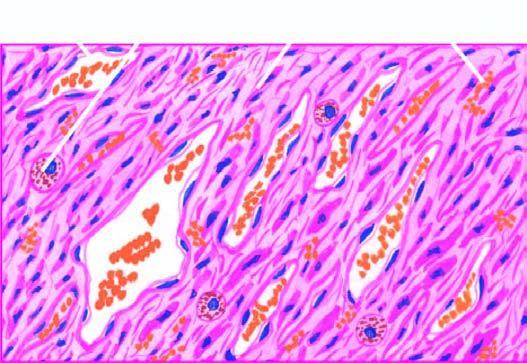re the intervening stroma slit-like blood-filled vascular spaces?
Answer the question using a single word or phrase. No 